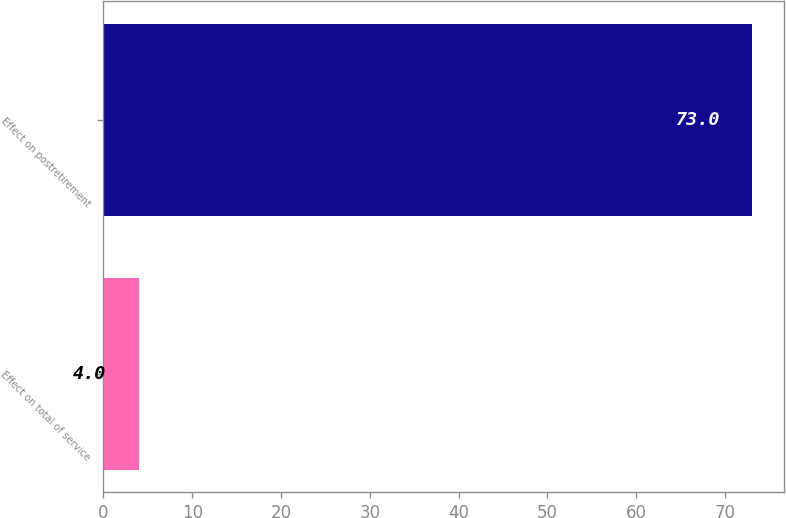<chart> <loc_0><loc_0><loc_500><loc_500><bar_chart><fcel>Effect on total of service<fcel>Effect on postretirement<nl><fcel>4<fcel>73<nl></chart> 